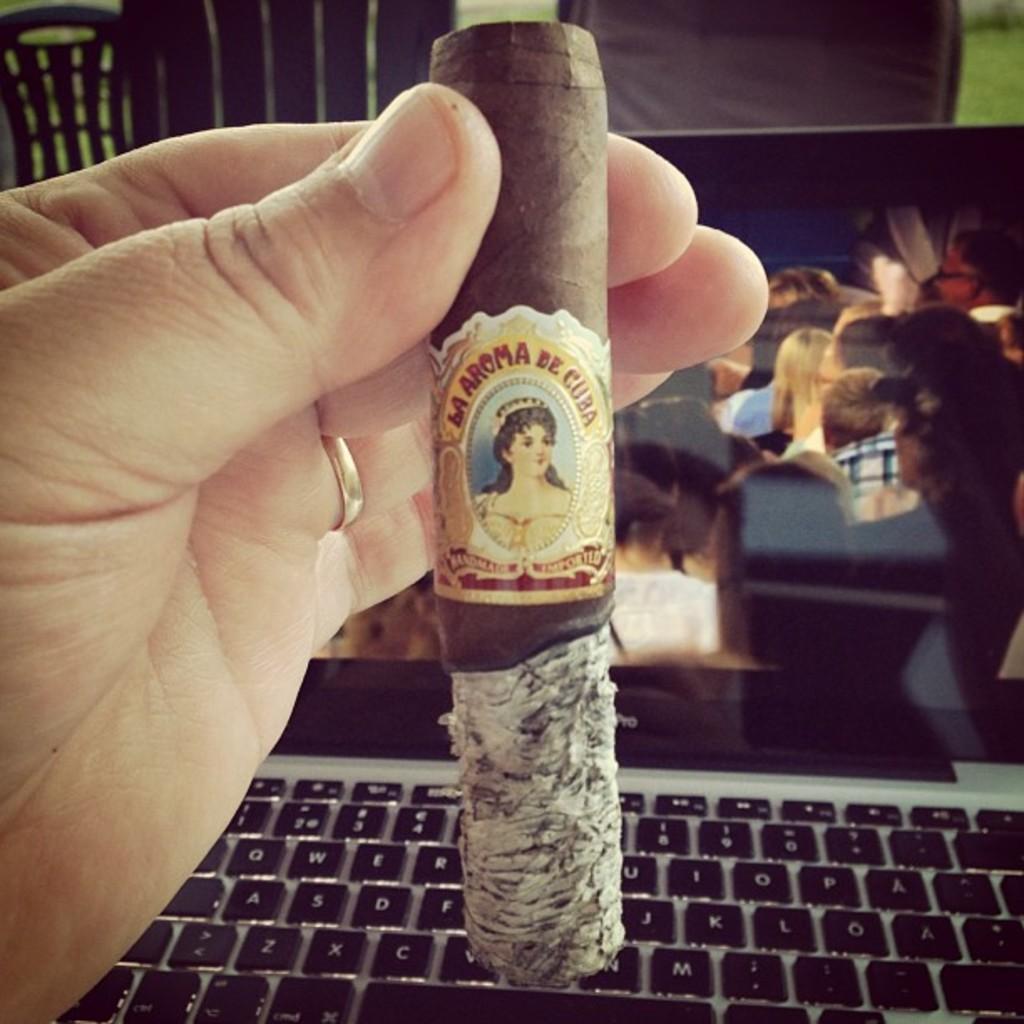Where was this cigar likely made?
Make the answer very short. Cuba. What is the brand of cigar?
Offer a terse response. La aroma de cuba. 